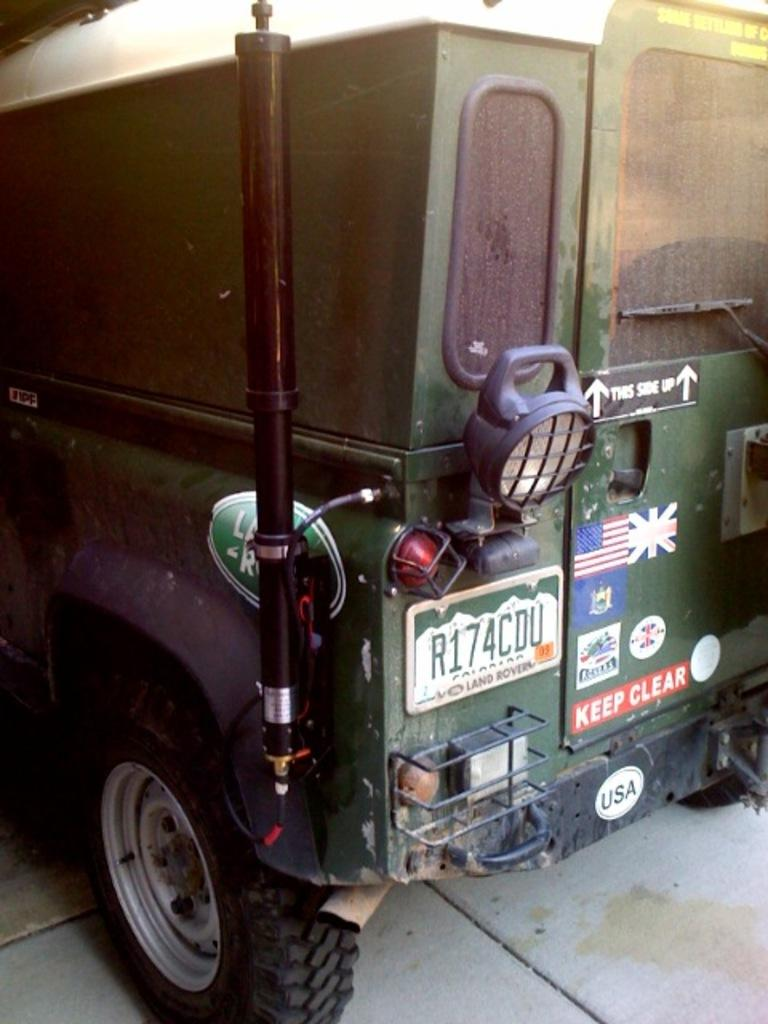What is the main subject of the image? The main subject of the image is a vehicle. Where is the vehicle located in the image? The vehicle is parked on the ground in the image. Is there any additional information about the vehicle? Yes, there is a name plate on the vehicle. What type of drug is the vehicle using in the image? There is no drug present in the image, and vehicles do not use drugs. 